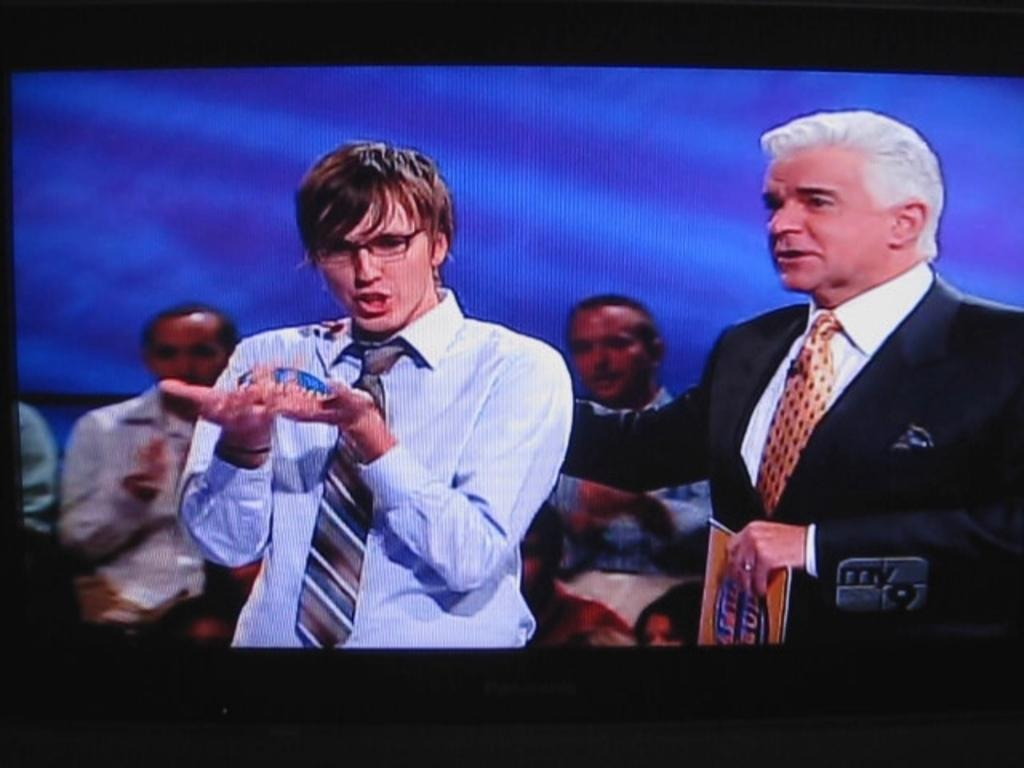<image>
Summarize the visual content of the image. My 9 tv channel is showing two men one who is gesturing with his hands. 